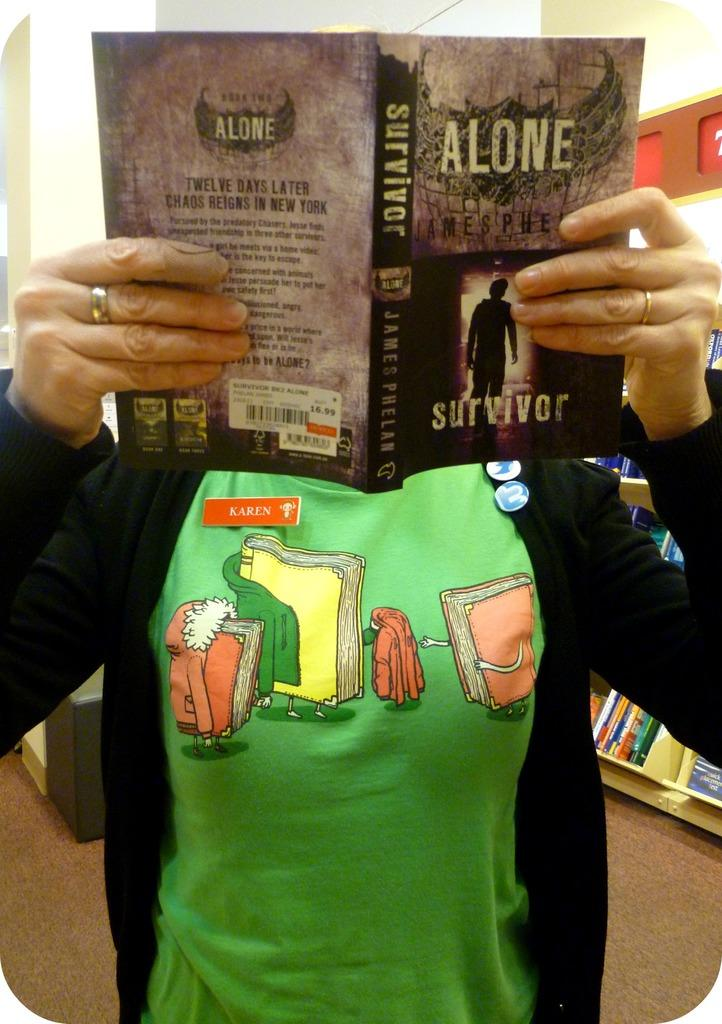<image>
Render a clear and concise summary of the photo. The book being read is called the Alone Survivor 